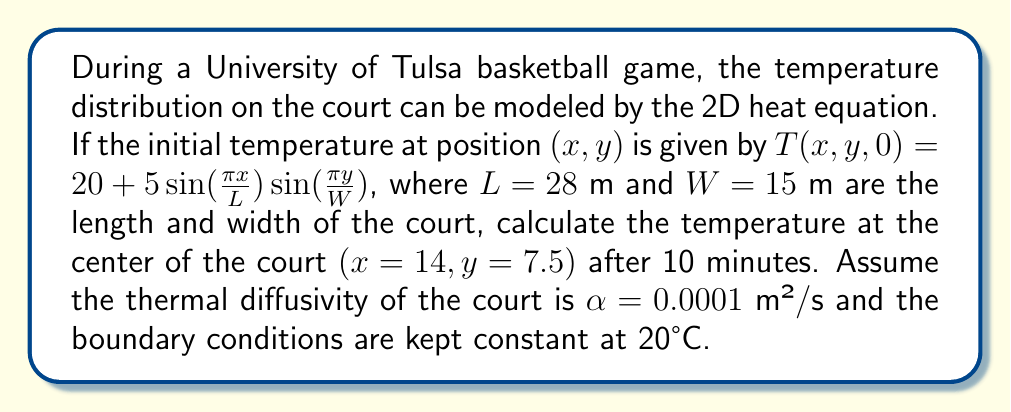Can you answer this question? Let's approach this step-by-step:

1) The 2D heat equation is given by:

   $$\frac{\partial T}{\partial t} = \alpha(\frac{\partial^2 T}{\partial x^2} + \frac{\partial^2 T}{\partial y^2})$$

2) The solution to this equation with the given initial conditions and constant boundary conditions is:

   $$T(x,y,t) = 20 + 5e^{-\alpha(\frac{\pi^2}{L^2}+\frac{\pi^2}{W^2})t}\sin(\frac{\pi x}{L})\sin(\frac{\pi y}{W})$$

3) We need to calculate this at:
   $x = 14$ m, $y = 7.5$ m, $t = 600$ s (10 minutes),
   $L = 28$ m, $W = 15$ m, $\alpha = 0.0001$ m²/s

4) First, let's calculate the exponent:

   $$-\alpha(\frac{\pi^2}{L^2}+\frac{\pi^2}{W^2})t = -0.0001(\frac{\pi^2}{28^2}+\frac{\pi^2}{15^2})600 \approx -0.0268$$

5) Now, let's calculate the sine terms:

   $$\sin(\frac{\pi x}{L}) = \sin(\frac{\pi 14}{28}) = \sin(\frac{\pi}{2}) = 1$$
   $$\sin(\frac{\pi y}{W}) = \sin(\frac{\pi 7.5}{15}) = \sin(\frac{\pi}{2}) = 1$$

6) Putting it all together:

   $$T(14,7.5,600) = 20 + 5e^{-0.0268} \cdot 1 \cdot 1 \approx 24.87°C$$
Answer: 24.87°C 